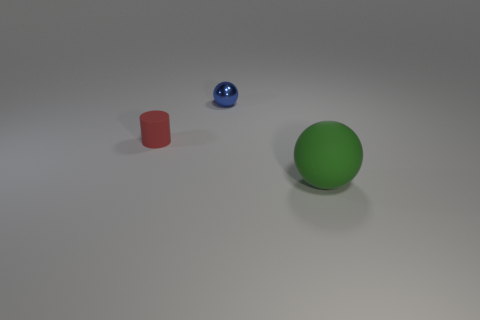Add 2 small rubber things. How many objects exist? 5 Subtract all balls. How many objects are left? 1 Add 1 small rubber cylinders. How many small rubber cylinders are left? 2 Add 3 red matte spheres. How many red matte spheres exist? 3 Subtract 0 blue cylinders. How many objects are left? 3 Subtract 1 cylinders. How many cylinders are left? 0 Subtract all gray cylinders. Subtract all red spheres. How many cylinders are left? 1 Subtract all red spheres. How many gray cylinders are left? 0 Subtract all red cylinders. Subtract all gray rubber cylinders. How many objects are left? 2 